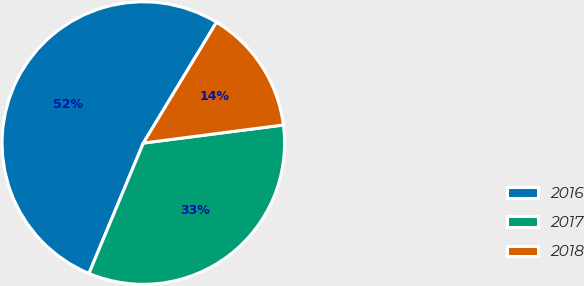Convert chart to OTSL. <chart><loc_0><loc_0><loc_500><loc_500><pie_chart><fcel>2016<fcel>2017<fcel>2018<nl><fcel>52.38%<fcel>33.33%<fcel>14.29%<nl></chart> 